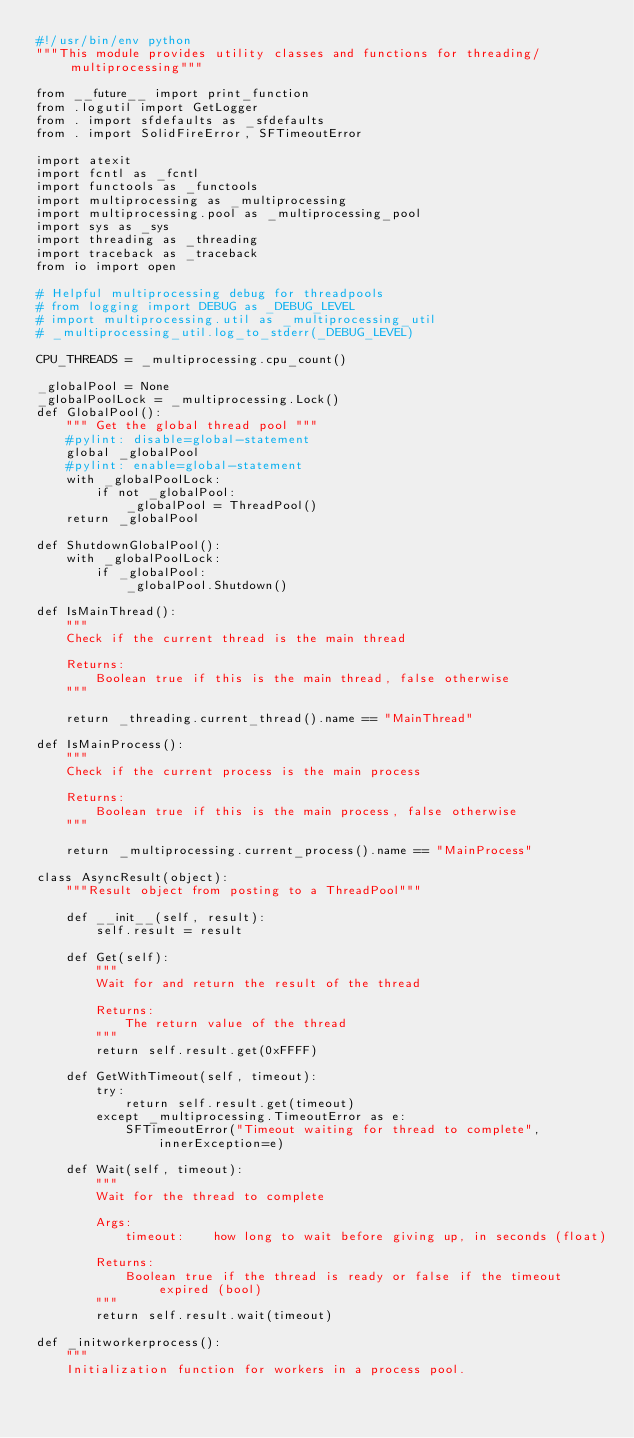<code> <loc_0><loc_0><loc_500><loc_500><_Python_>#!/usr/bin/env python
"""This module provides utility classes and functions for threading/multiprocessing"""

from __future__ import print_function
from .logutil import GetLogger
from . import sfdefaults as _sfdefaults
from . import SolidFireError, SFTimeoutError

import atexit
import fcntl as _fcntl
import functools as _functools
import multiprocessing as _multiprocessing
import multiprocessing.pool as _multiprocessing_pool
import sys as _sys
import threading as _threading
import traceback as _traceback
from io import open

# Helpful multiprocessing debug for threadpools
# from logging import DEBUG as _DEBUG_LEVEL
# import multiprocessing.util as _multiprocessing_util
# _multiprocessing_util.log_to_stderr(_DEBUG_LEVEL)

CPU_THREADS = _multiprocessing.cpu_count()

_globalPool = None
_globalPoolLock = _multiprocessing.Lock()
def GlobalPool():
    """ Get the global thread pool """
    #pylint: disable=global-statement
    global _globalPool
    #pylint: enable=global-statement
    with _globalPoolLock:
        if not _globalPool:
            _globalPool = ThreadPool()
    return _globalPool

def ShutdownGlobalPool():
    with _globalPoolLock:
        if _globalPool:
            _globalPool.Shutdown()

def IsMainThread():
    """
    Check if the current thread is the main thread
    
    Returns:
        Boolean true if this is the main thread, false otherwise
    """

    return _threading.current_thread().name == "MainThread"

def IsMainProcess():
    """
    Check if the current process is the main process
    
    Returns:
        Boolean true if this is the main process, false otherwise
    """

    return _multiprocessing.current_process().name == "MainProcess"

class AsyncResult(object):
    """Result object from posting to a ThreadPool"""

    def __init__(self, result):
        self.result = result

    def Get(self):
        """
        Wait for and return the result of the thread

        Returns:
            The return value of the thread
        """
        return self.result.get(0xFFFF)

    def GetWithTimeout(self, timeout):
        try:
            return self.result.get(timeout)
        except _multiprocessing.TimeoutError as e:
            SFTimeoutError("Timeout waiting for thread to complete", innerException=e)

    def Wait(self, timeout):
        """
        Wait for the thread to complete

        Args:
            timeout:    how long to wait before giving up, in seconds (float)

        Returns:
            Boolean true if the thread is ready or false if the timeout expired (bool)
        """
        return self.result.wait(timeout)

def _initworkerprocess():
    """
    Initialization function for workers in a process pool.</code> 